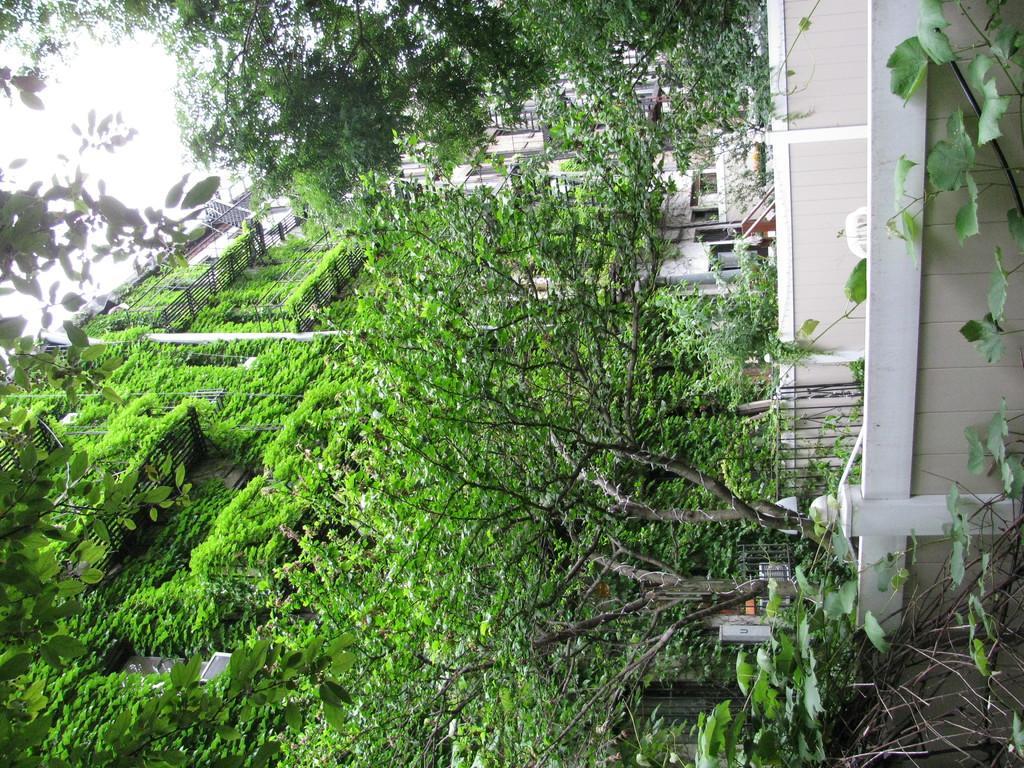In one or two sentences, can you explain what this image depicts? In front of the image there are walls. There is a metal fence. In the background of the image there are buildings, trees, creepers. At the top of the image there is sky. 